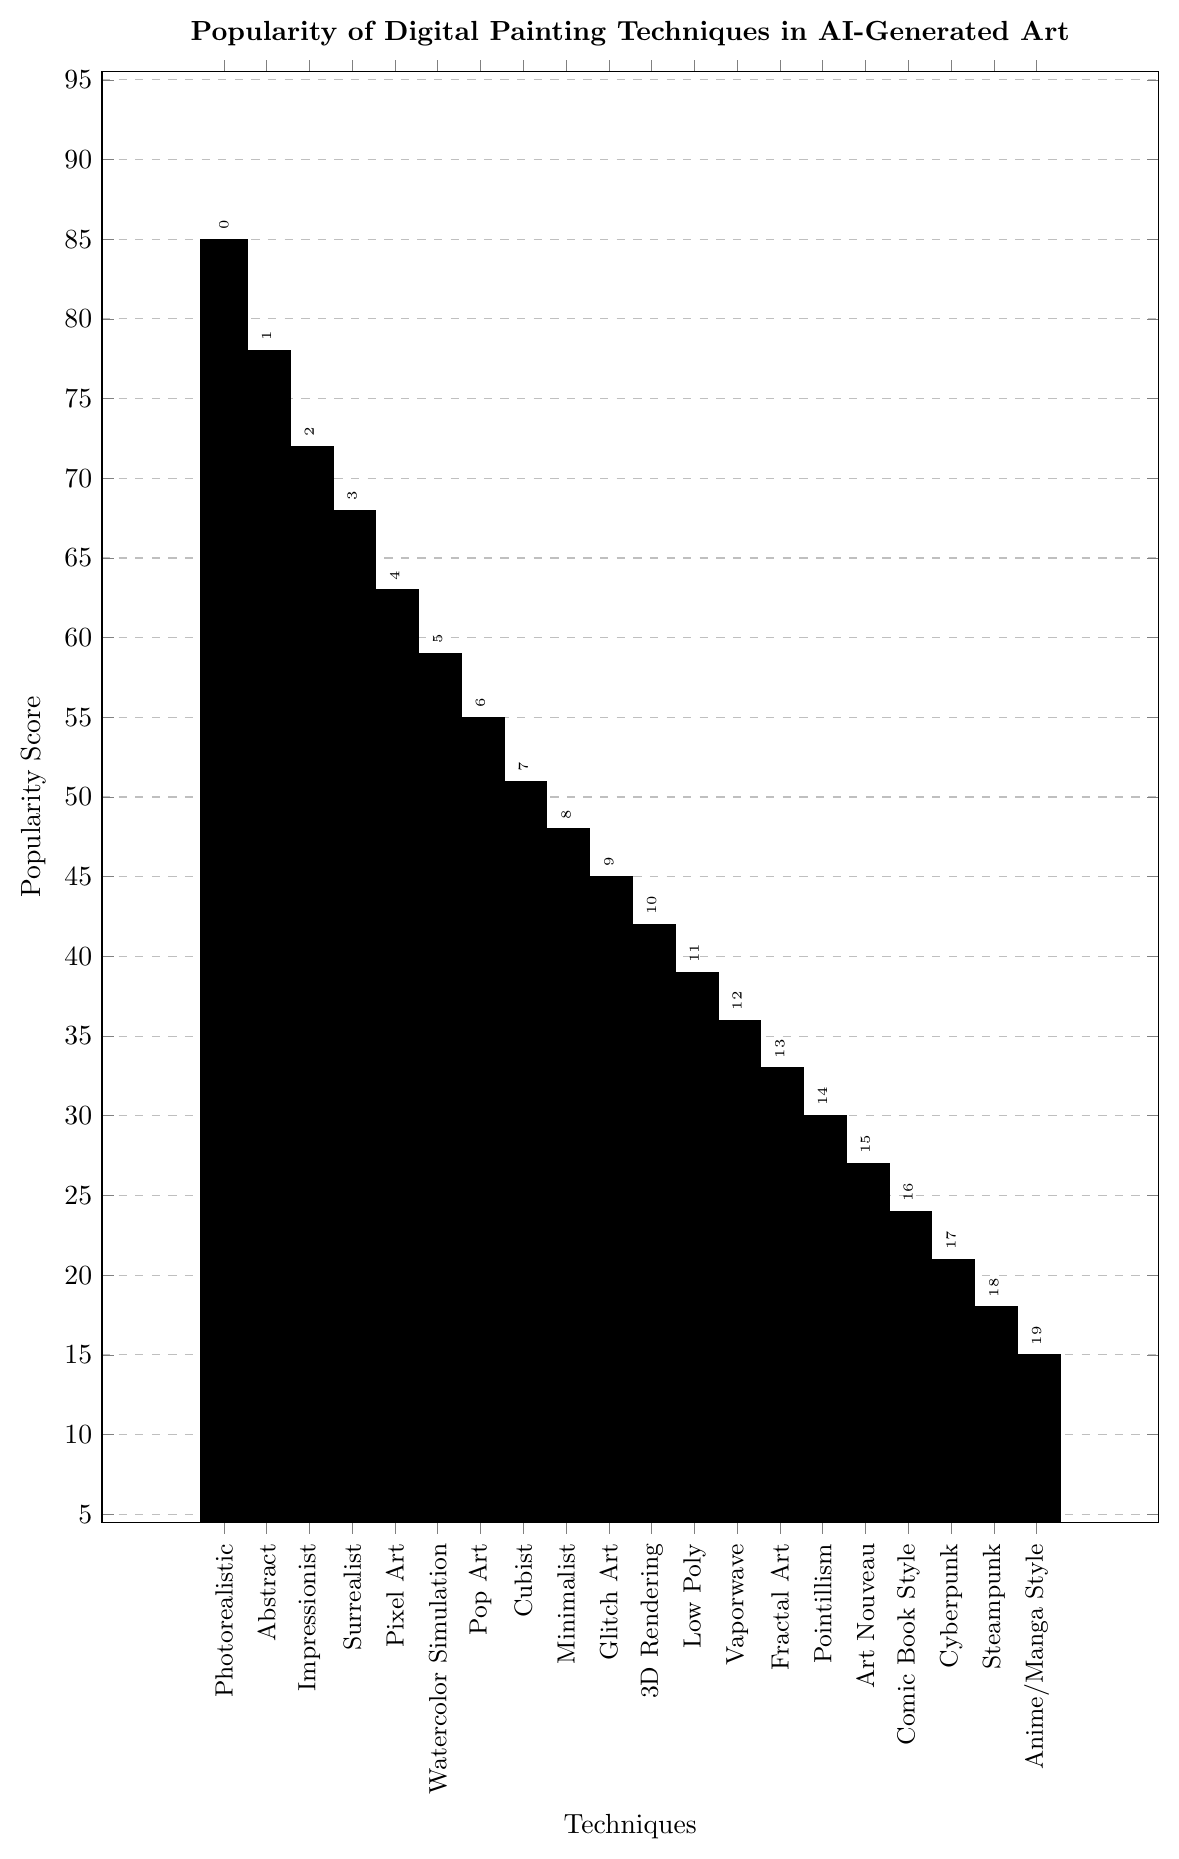What's the most popular digital painting technique in AI-generated art according to the chart? The chart shows the popularity score for each technique. The highest bar represents the most popular technique, which is "Photorealistic" with a score of 85.
Answer: Photorealistic Which digital painting technique has a popularity score of 45? By visually identifying the bar with a height corresponding to a score of 45, we can see that the "Glitch Art" technique matches this score.
Answer: Glitch Art What is the difference in popularity score between the "Photorealistic" and "Anime/Manga Style" techniques? The popularity score for "Photorealistic" is 85 and for "Anime/Manga Style" is 15. Subtracting 15 from 85 gives 85 - 15 = 70.
Answer: 70 Which techniques have higher or equal popularity scores compared to "Pixel Art"? "Pixel Art" has a popularity score of 63. Techniques with scores equal to or greater than 63 are "Photorealistic" (85), "Abstract" (78), "Impressionist" (72), "Surrealist" (68), and "Pixel Art" (63).
Answer: Photorealistic, Abstract, Impressionist, Surrealist, Pixel Art Compare the popularity of "Watercolor Simulation" and "Low Poly". Which one is more popular and by how much? "Watercolor Simulation" has a score of 59, while "Low Poly" has a score of 39. Subtracting 39 from 59 gives 59 - 39 = 20. "Watercolor Simulation" is more popular by 20 points.
Answer: Watercolor Simulation by 20 Identify the digital painting technique occupying the median position in popularity scores. To find the median position, sort all scores and find the middle one. There are 20 techniques, so the median will be the average of the 10th and 11th scores in the sorted list. Sorted scores: {15, 18, 21, 24, 27, 30, 33, 36, 39, 42, 45, 48, 51, 55, 59, 63, 68, 72, 78, 85}. The 10th and 11th positions are "3D Rendering" (42) and "Glitch Art" (45). The median value is (42 + 45)/2 = 43.5. Both "3D Rendering" and "Glitch Art" are around the median position.
Answer: 3D Rendering / Glitch Art What is the average popularity score of the top three most popular techniques? The top three techniques are "Photorealistic" (85), "Abstract" (78), and "Impressionist" (72). The average is calculated as (85 + 78 + 72) / 3 = 235 / 3 ≈ 78.33.
Answer: 78.33 How many techniques have a popularity score below 40? Visual inspection of the chart shows that the techniques with scores below 40 are "Low Poly" (39), "Vaporwave" (36), "Fractal Art" (33), "Pointillism" (30), "Art Nouveau" (27), "Comic Book Style" (24), "Cyberpunk" (21), "Steampunk" (18), and "Anime/Manga Style" (15). There are 9 such techniques.
Answer: 9 Rank the techniques with a popularity score greater than or equal to 50, from most to least popular. Techniques with scores ≥ 50 are (sorted in descending order): "Photorealistic" (85), "Abstract" (78), "Impressionist" (72), "Surrealist" (68), "Pixel Art" (63), "Watercolor Simulation" (59), "Pop Art" (55), and "Cubist" (51).
Answer: Photorealistic, Abstract, Impressionist, Surrealist, Pixel Art, Watercolor Simulation, Pop Art, Cubist Which technique appears last in terms of popularity and what is its score? The shortest bar on the chart shows that the "Anime/Manga Style" is the least popular technique with a score of 15.
Answer: Anime/Manga Style, 15 